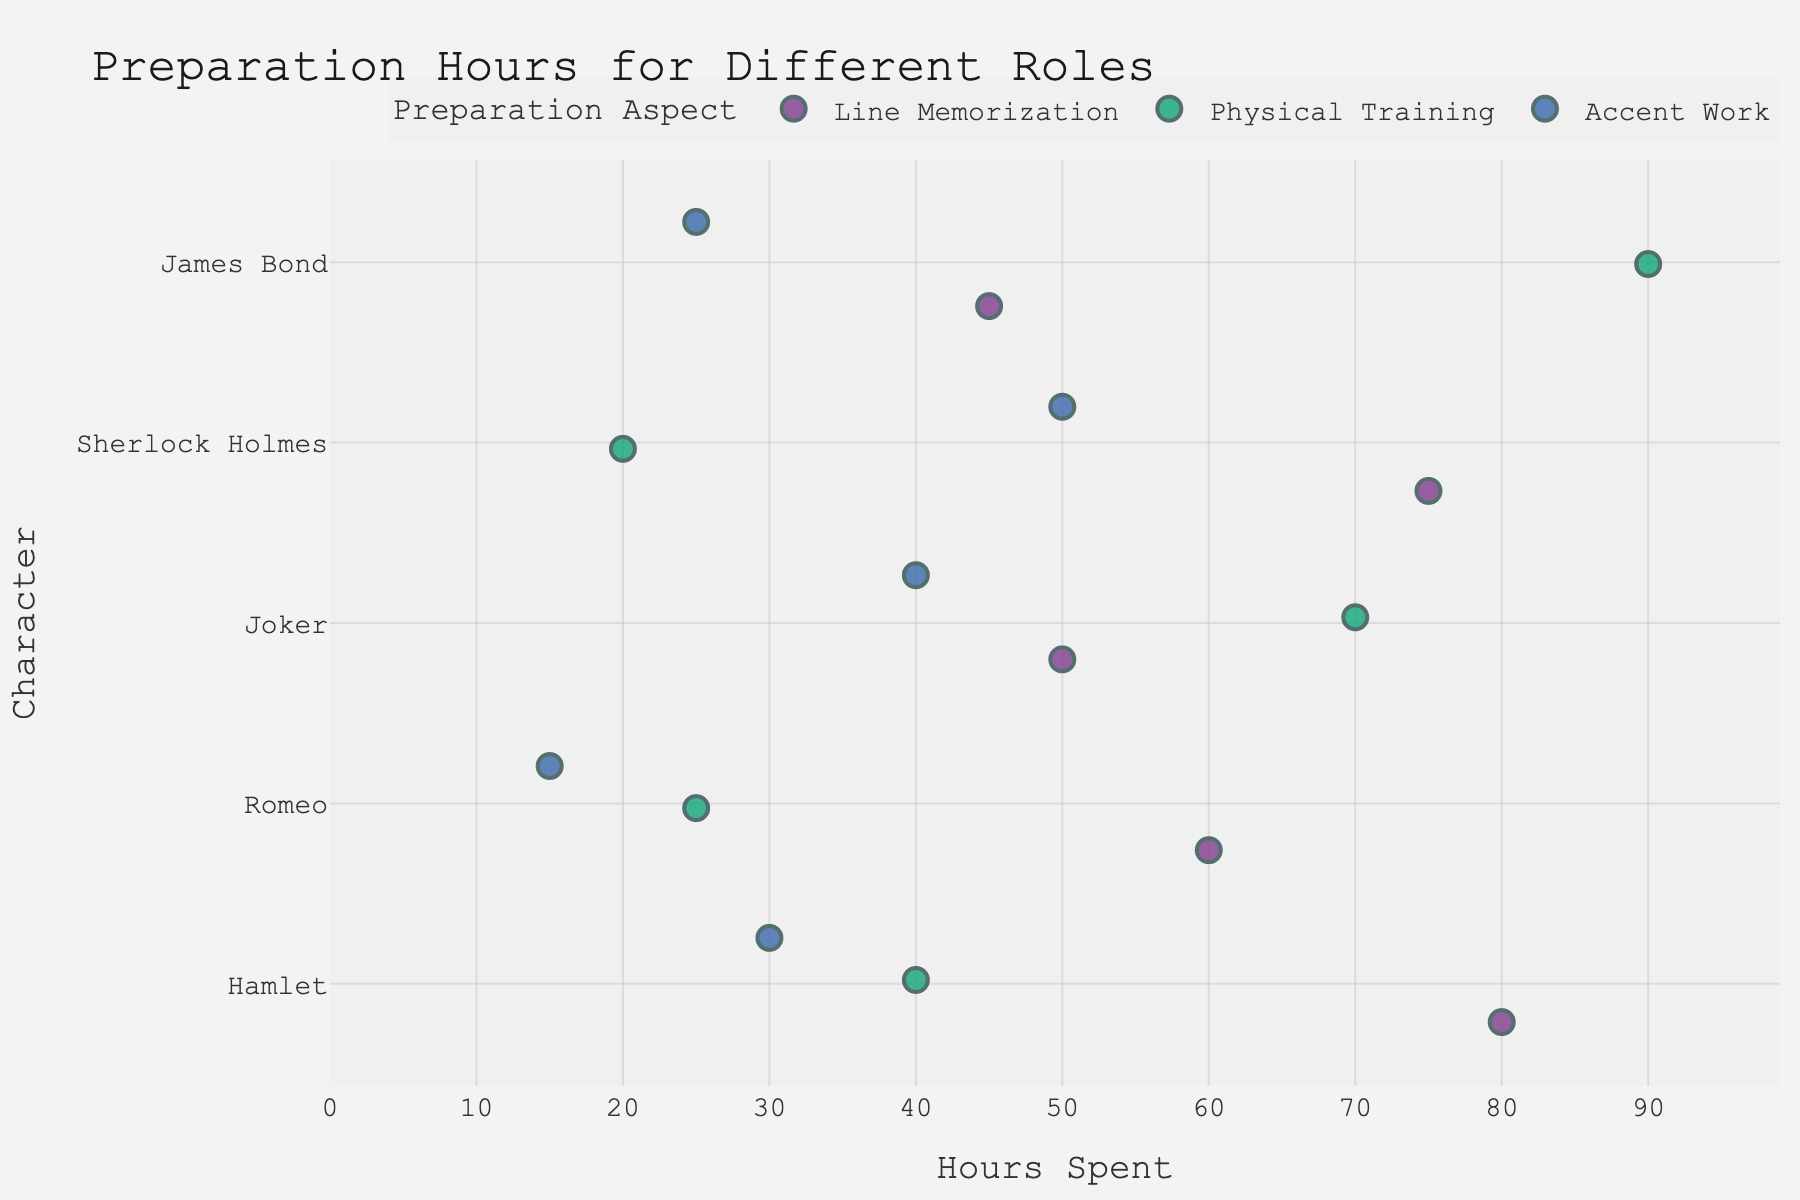What is the title of the figure? The title of the figure is located at the top center of the chart.
Answer: Preparation Hours for Different Roles Which role required the most physical training hours? By looking at the Physical Training category, identify the role with the highest value on the x-axis.
Answer: James Bond How many hours did Romeo spend on accent work? Find the data point for Romeo under the Accent Work category on the figure and note the x-axis value.
Answer: 15 Which role had the highest total preparation hours? Sum the hours spent on all aspects (Line Memorization, Physical Training, Accent Work) for each role and identify the highest one.
Answer: Hamlet Compare the amount of time spent on line memorization for Hamlet and James Bond, which one is higher? Identify the line memorization points for Hamlet and James Bond, and compare their x-axis values.
Answer: Hamlet What is the average number of hours spent on physical training across all roles? Sum the physical training hours of all roles (40 + 25 + 70 + 20 + 90) and divide by the number of roles (5).
Answer: 49 Which preparation aspect for the character Joker took the least amount of time? Identify the three data points for Joker and compare their x-axis values to find the lowest one.
Answer: Line Memorization In which aspect did Sherlock Holmes and James Bond spend an equal number of hours? Look for matching data points in hours for Sherlock Holmes and James Bond in the three categories.
Answer: Accent Work Which role required exactly 45 hours for line memorization? Find the data point under the Line Memorization category that has an x-axis value of 45 and check the corresponding role.
Answer: James Bond How many roles required more than 50 hours on physical training? Check all roles under the Physical Training category and count how many have x-axis values greater than 50.
Answer: 2 